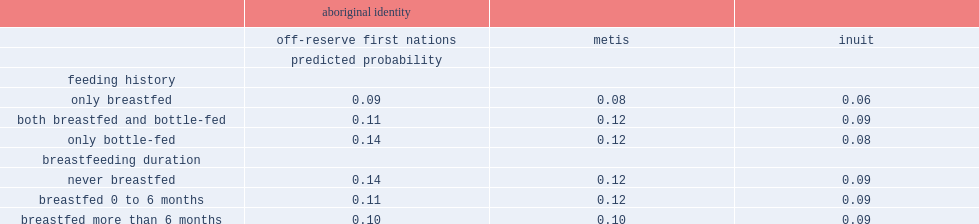Which feeding history were first nations children living off reserve less likely to have asthma/chronic bronchitis, who were only breastfed or who were only bottle-fed? Only breastfed. What was the percent of children who were breastfed up to six months to have asthma/chronic bronchitis? 0.11. What was the percent of children who were breastfed more than six months to have asthma/chronic bronchitis? 0.1. What was the percent of children who were never breastfed to have asthma/chronic bronchitis? 0.14. 